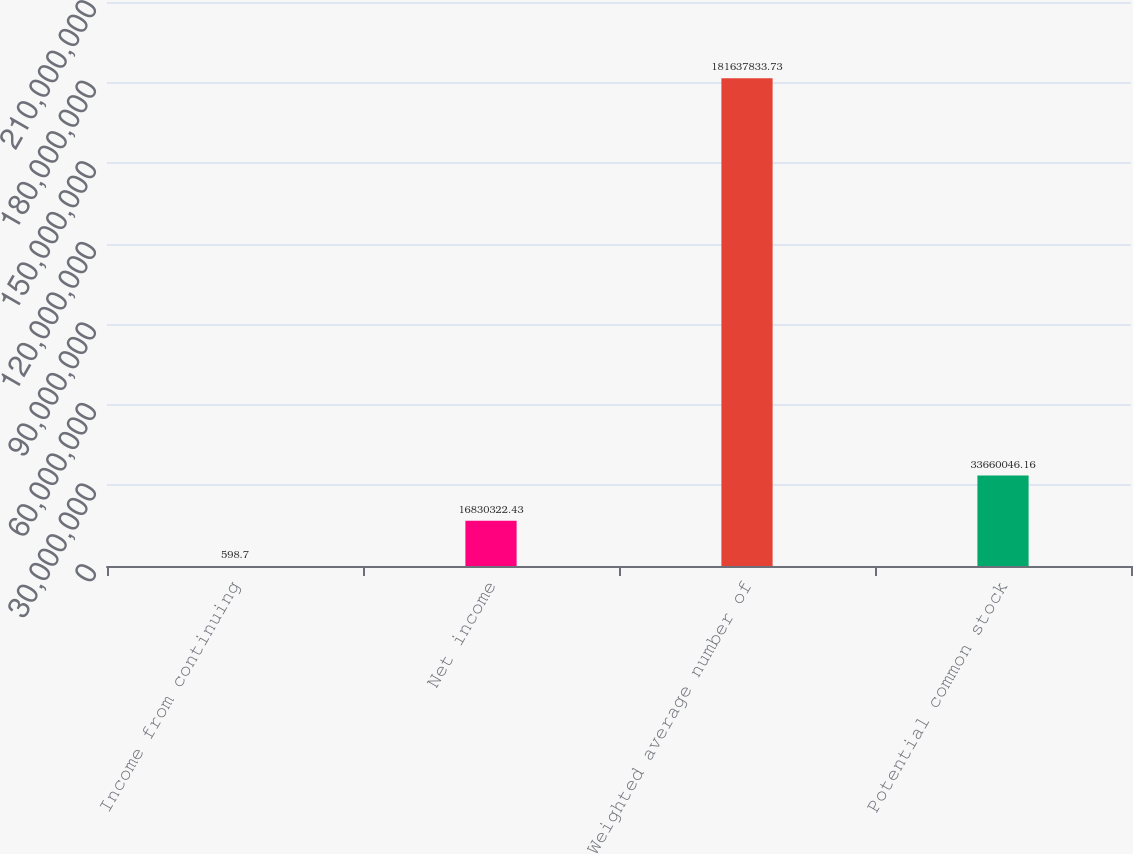Convert chart. <chart><loc_0><loc_0><loc_500><loc_500><bar_chart><fcel>Income from continuing<fcel>Net income<fcel>Weighted average number of<fcel>Potential common stock<nl><fcel>598.7<fcel>1.68303e+07<fcel>1.81638e+08<fcel>3.366e+07<nl></chart> 